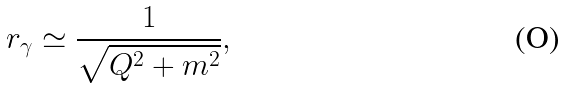<formula> <loc_0><loc_0><loc_500><loc_500>r _ { \gamma } \simeq \frac { 1 } { \sqrt { Q ^ { 2 } + m ^ { 2 } } } ,</formula> 